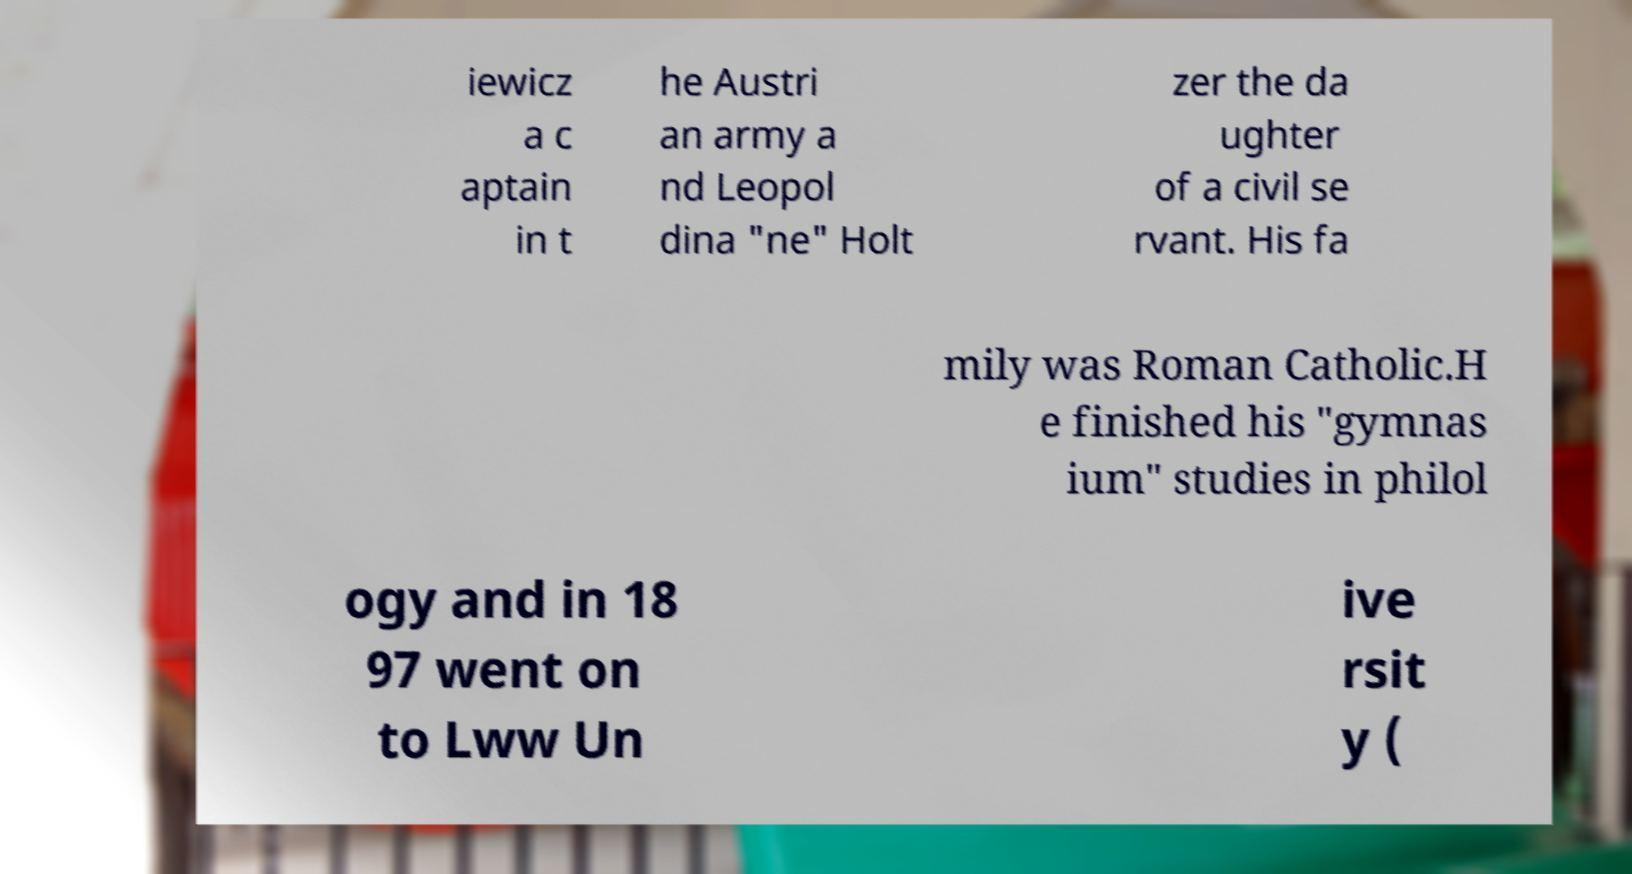I need the written content from this picture converted into text. Can you do that? iewicz a c aptain in t he Austri an army a nd Leopol dina "ne" Holt zer the da ughter of a civil se rvant. His fa mily was Roman Catholic.H e finished his "gymnas ium" studies in philol ogy and in 18 97 went on to Lww Un ive rsit y ( 